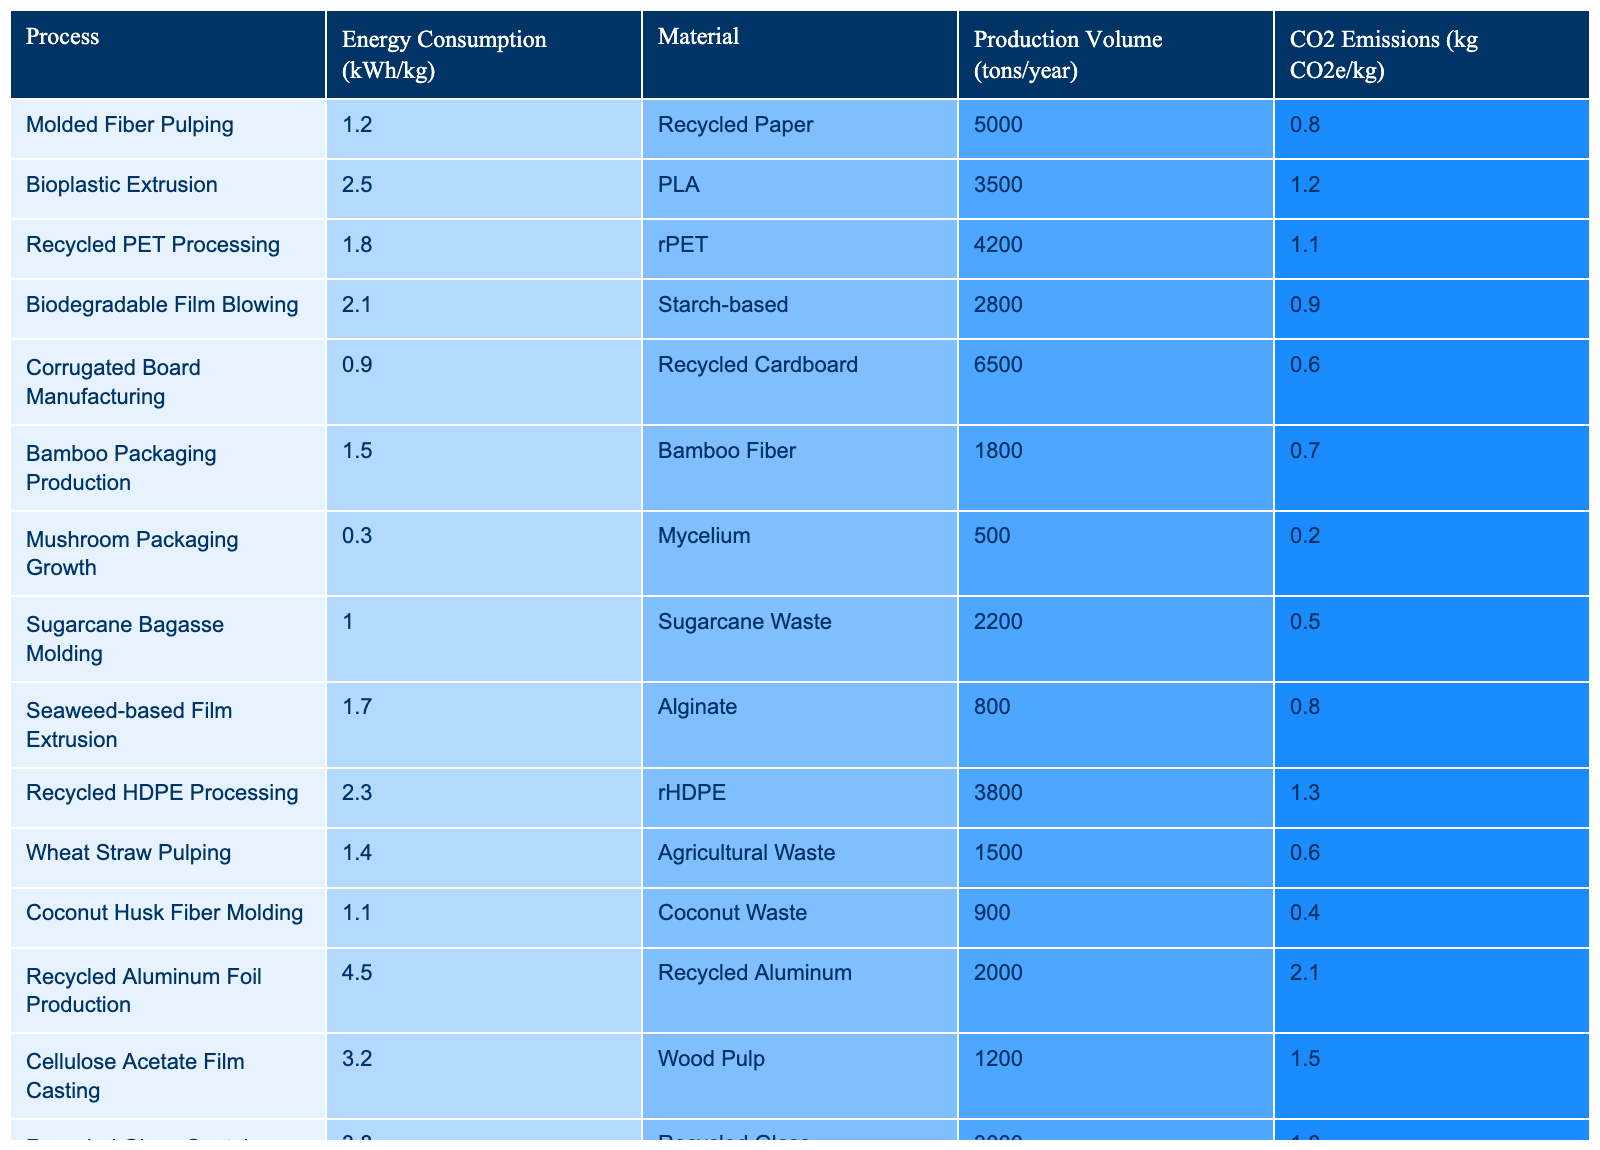What is the energy consumption for Recycled PET Processing? The table indicates that the energy consumption for Recycled PET Processing is listed as 1.8 kWh/kg.
Answer: 1.8 kWh/kg Which process has the lowest energy consumption? According to the table, Molded Fiber Pulping has the lowest energy consumption at 1.2 kWh/kg.
Answer: 1.2 kWh/kg What is the total production volume of all processes combined? Adding the production volumes: 5000 + 3500 + 4200 + 2800 + 6500 + 1800 + 500 + 2200 + 800 + 3800 + 1500 + 900 + 2000 + 1200 + 3000 = 22500 tons/year.
Answer: 22500 tons/year Is it true that Bioplastic Extrusion has higher CO2 emissions than Mushroom Packaging Growth? The table shows that Bioplastic Extrusion emits 1.2 kg CO2e/kg while Mushroom Packaging Growth emits 0.2 kg CO2e/kg, making the statement true.
Answer: True Which process has the highest CO2 emissions, and what is its value? The table reveals that Recycled Aluminum Foil Production has the highest CO2 emissions at 2.1 kg CO2e/kg.
Answer: 2.1 kg CO2e/kg What is the average energy consumption for the processes involving agricultural waste materials? The processes with agricultural waste are Wheat Straw Pulping (1.4 kWh/kg) and Mushroom Packaging Growth (0.3 kWh/kg). The average is (1.4 + 0.3) / 2 = 0.85 kWh/kg.
Answer: 0.85 kWh/kg Does the energy consumption vary significantly between corrugated board manufacturing and bamboo packaging production? The values are 0.9 kWh/kg for corrugated board manufacturing and 1.5 kWh/kg for bamboo packaging production, indicating a difference of 0.6 kWh/kg, which can be considered significant.
Answer: Yes What is the total CO2 emissions from all processes for a production volume of 10 tons? To calculate total CO2 emissions: 
(5000 * 0.8) + (3500 * 1.2) + (4200 * 1.1) + (2800 * 0.9) + (6500 * 0.6) + (1800 * 0.7) + (500 * 0.2) + (2200 * 0.5) + (800 * 0.8) + (3800 * 1.3) + (1500 * 0.6) + (900 * 0.4) + (2000 * 2.1) + (1200 * 1.5) + (3000 * 1.8) = total emissions in kg CO2e. For 10 tons, it becomes too complex to summarize in a single number without conducting a detailed calculation.
Answer: 10 tons not applicable for direct total Which process, according to the table, has the highest energy consumption and is made of recycled materials? Recycled HDPE Processing has an energy consumption of 2.3 kWh/kg and is made from recycled materials, making it the highest for that category.
Answer: Recycled HDPE Processing What is the production volume of Biodegradable Film Blowing? The table lists the production volume of Biodegradable Film Blowing as 2800 tons/year.
Answer: 2800 tons/year 